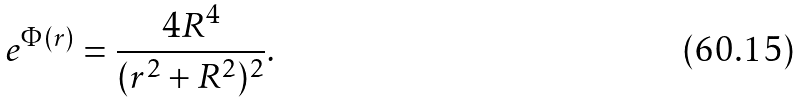<formula> <loc_0><loc_0><loc_500><loc_500>e ^ { \Phi ( r ) } = { \frac { 4 R ^ { 4 } } { ( r ^ { 2 } + R ^ { 2 } ) ^ { 2 } } } .</formula> 